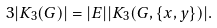Convert formula to latex. <formula><loc_0><loc_0><loc_500><loc_500>3 | K _ { 3 } ( G ) | = | E | | K _ { 3 } ( G , \{ x , y \} ) | .</formula> 